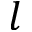Convert formula to latex. <formula><loc_0><loc_0><loc_500><loc_500>l</formula> 